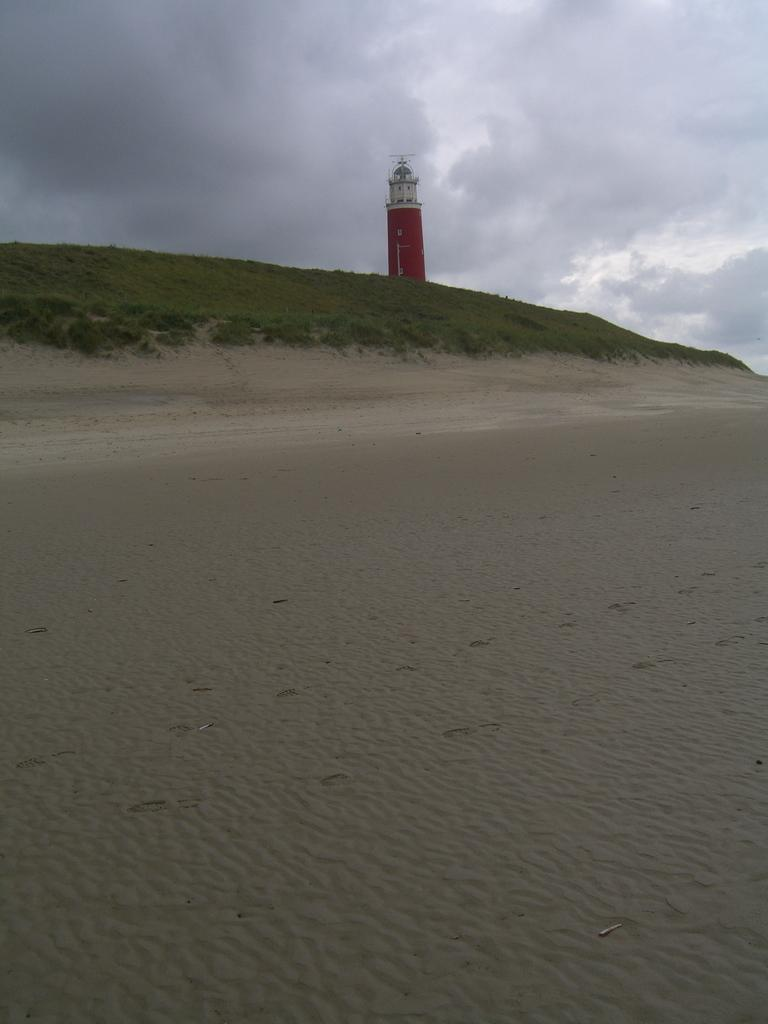What type of terrain is visible in the image? There is sand in the image. What type of vegetation can be seen in the background of the image? There is grass in the background of the image. What type of structure is visible in the background of the image? There is a lighthouse in the background of the image. What is the condition of the sky in the background of the image? The sky is cloudy in the background of the image. What type of amusement can be seen on the roof of the lighthouse in the image? There is no amusement or roof present on the lighthouse in the image. 